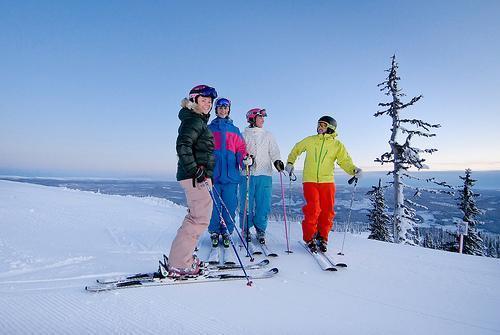How many people in the photo?
Give a very brief answer. 4. How many ski poles can actually be seen?
Give a very brief answer. 7. 